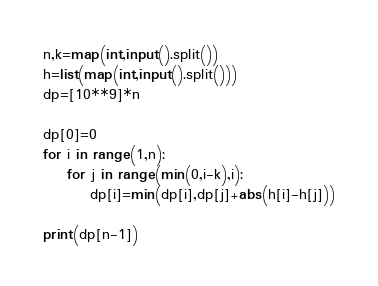<code> <loc_0><loc_0><loc_500><loc_500><_Python_>n,k=map(int,input().split())
h=list(map(int,input().split()))
dp=[10**9]*n

dp[0]=0
for i in range(1,n):
    for j in range(min(0,i-k),i):
        dp[i]=min(dp[i],dp[j]+abs(h[i]-h[j]))
    
print(dp[n-1])</code> 